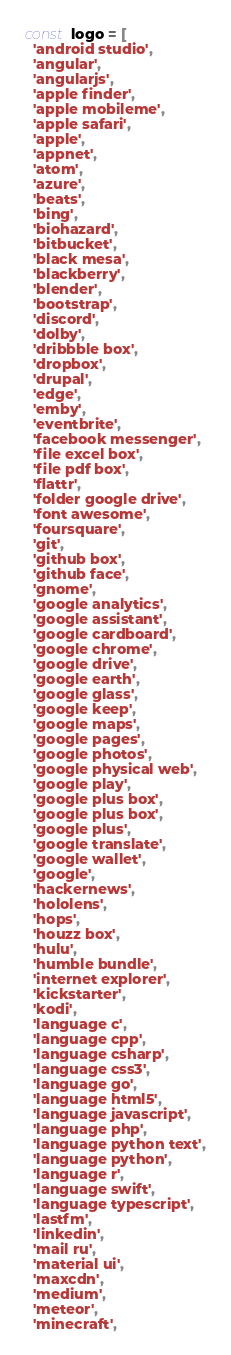Convert code to text. <code><loc_0><loc_0><loc_500><loc_500><_JavaScript_>const logo = [
  'android studio',
  'angular',
  'angularjs',
  'apple finder',
  'apple mobileme',
  'apple safari',
  'apple',
  'appnet',
  'atom',
  'azure',
  'beats',
  'bing',
  'biohazard',
  'bitbucket',
  'black mesa',
  'blackberry',
  'blender',
  'bootstrap',
  'discord',
  'dolby',
  'dribbble box',
  'dropbox',
  'drupal',
  'edge',
  'emby',
  'eventbrite',
  'facebook messenger',
  'file excel box',
  'file pdf box',
  'flattr',
  'folder google drive',
  'font awesome',
  'foursquare',
  'git',
  'github box',
  'github face',
  'gnome',
  'google analytics',
  'google assistant',
  'google cardboard',
  'google chrome',
  'google drive',
  'google earth',
  'google glass',
  'google keep',
  'google maps',
  'google pages',
  'google photos',
  'google physical web',
  'google play',
  'google plus box',
  'google plus box',
  'google plus',
  'google translate',
  'google wallet',
  'google',
  'hackernews',
  'hololens',
  'hops',
  'houzz box',
  'hulu',
  'humble bundle',
  'internet explorer',
  'kickstarter',
  'kodi',
  'language c',
  'language cpp',
  'language csharp',
  'language css3',
  'language go',
  'language html5',
  'language javascript',
  'language php',
  'language python text',
  'language python',
  'language r',
  'language swift',
  'language typescript',
  'lastfm',
  'linkedin',
  'mail ru',
  'material ui',
  'maxcdn',
  'medium',
  'meteor',
  'minecraft',</code> 